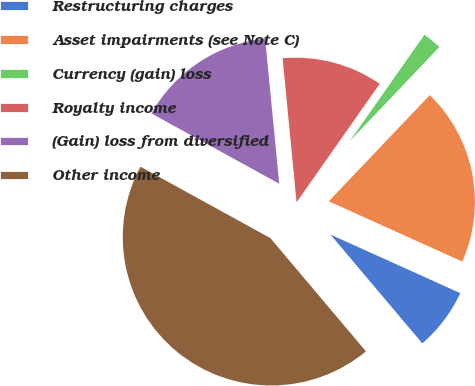<chart> <loc_0><loc_0><loc_500><loc_500><pie_chart><fcel>Restructuring charges<fcel>Asset impairments (see Note C)<fcel>Currency (gain) loss<fcel>Royalty income<fcel>(Gain) loss from diversified<fcel>Other income<nl><fcel>7.1%<fcel>19.64%<fcel>2.37%<fcel>11.28%<fcel>15.46%<fcel>44.16%<nl></chart> 